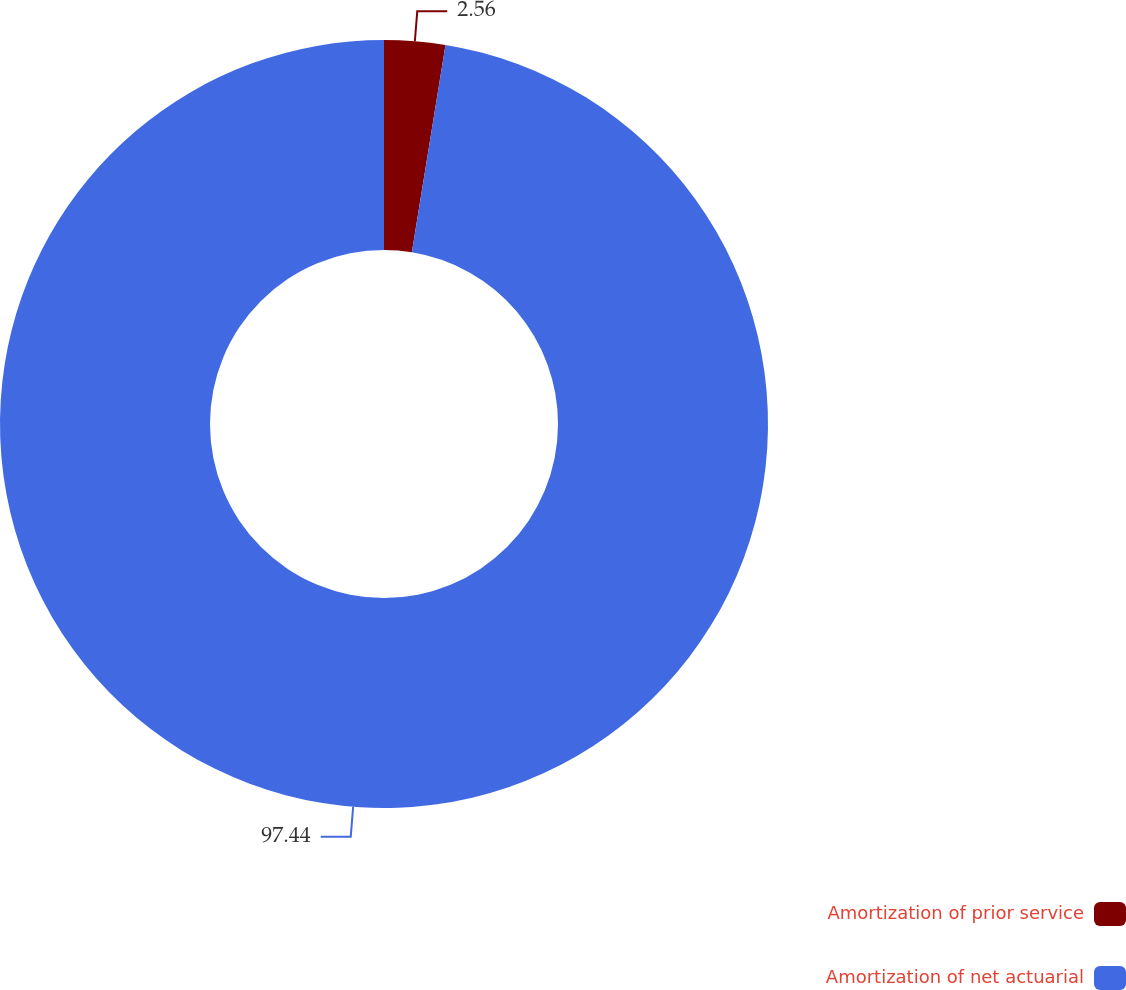Convert chart. <chart><loc_0><loc_0><loc_500><loc_500><pie_chart><fcel>Amortization of prior service<fcel>Amortization of net actuarial<nl><fcel>2.56%<fcel>97.44%<nl></chart> 